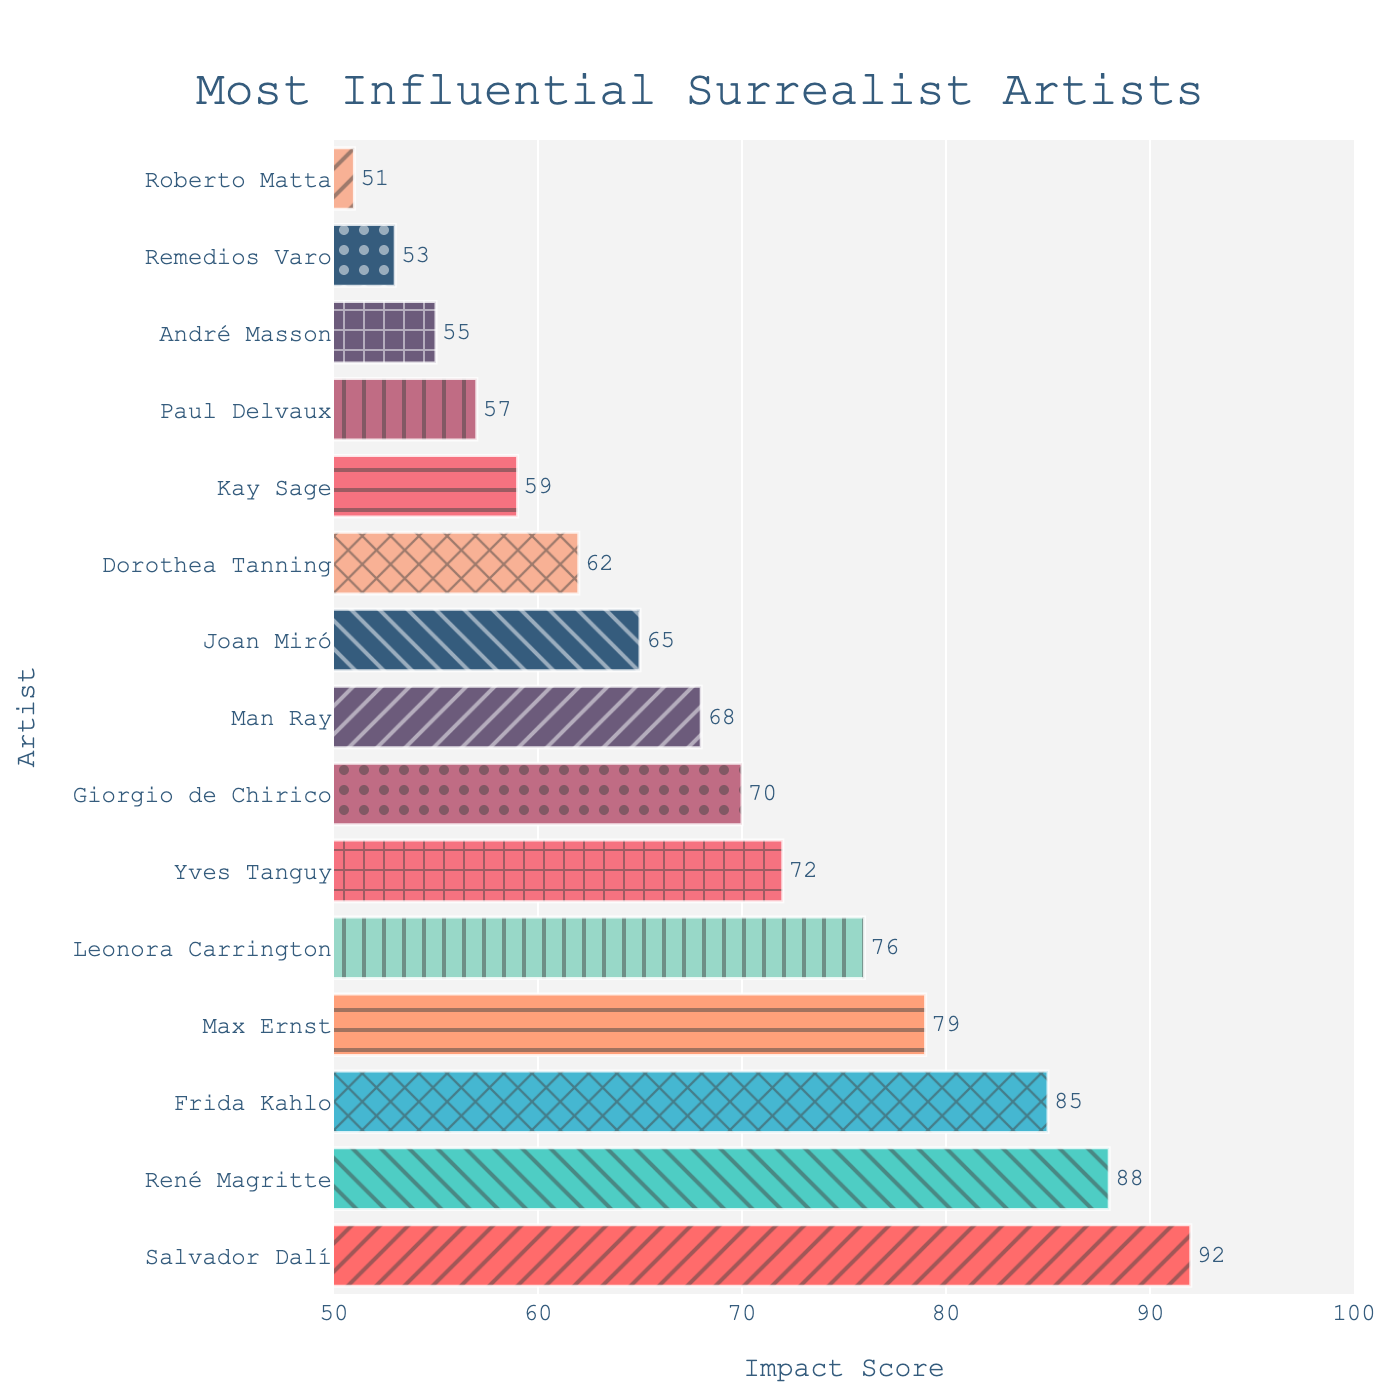Which artist has the highest impact score? According to the bar chart, Salvador Dalí has the highest bar, indicating the highest impact score.
Answer: Salvador Dalí Which artist has the lowest impact score? The bar representing Roberto Matta is the shortest among all, indicating the lowest impact score.
Answer: Roberto Matta What is the difference in impact score between Salvador Dalí and René Magritte? Salvador Dalí has an impact score of 92 and René Magritte has an impact score of 88. The difference in their impact scores is 92 - 88.
Answer: 4 Who are the top three artists in terms of impact score? The top three tallest bars represent Salvador Dalí, René Magritte, and Frida Kahlo, with scores 92, 88, and 85 respectively.
Answer: Salvador Dalí, René Magritte, Frida Kahlo What is the combined impact score of the bottom three artists? The bars representing Paul Delvaux, André Masson, and Roberto Matta have impact scores of 57, 55, and 51 respectively. Combined, this is 57 + 55 + 51.
Answer: 163 How many artists have an impact score greater than or equal to 80? There are four bars with impact scores 92 (Salvador Dalí), 88 (René Magritte), 85 (Frida Kahlo), and 79 (Max Ernst), but only the first three are greater than or equal to 80.
Answer: 3 Which artists have impact scores between 70 and 80? The bars corresponding to Max Ernst (79), Leonora Carrington (76), and Yves Tanguy (72) fall within this range.
Answer: Max Ernst, Leonora Carrington, Yves Tanguy What's the average impact score of the top 5 artists? The impact scores for the top five artists (Salvador Dalí, René Magritte, Frida Kahlo, Max Ernst, and Leonora Carrington) are 92, 88, 85, 79, and 76 respectively. The average score is (92 + 88 + 85 + 79 + 76) / 5.
Answer: 84 Which artists have bars with patterned markers in the chart? By observing the chart, each bar has a unique pattern design, thus all 15 artists have bars with patterned markers.
Answer: All Which artist's bar color is closest to red? The bar for Salvador Dalí appears to be the closest to red.
Answer: Salvador Dalí 